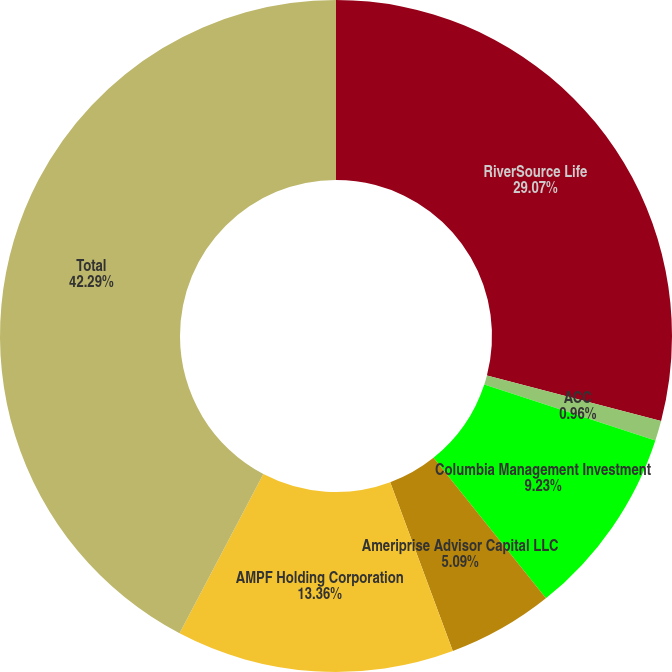<chart> <loc_0><loc_0><loc_500><loc_500><pie_chart><fcel>RiverSource Life<fcel>ACC<fcel>Columbia Management Investment<fcel>Ameriprise Advisor Capital LLC<fcel>AMPF Holding Corporation<fcel>Total<nl><fcel>29.07%<fcel>0.96%<fcel>9.23%<fcel>5.09%<fcel>13.36%<fcel>42.29%<nl></chart> 